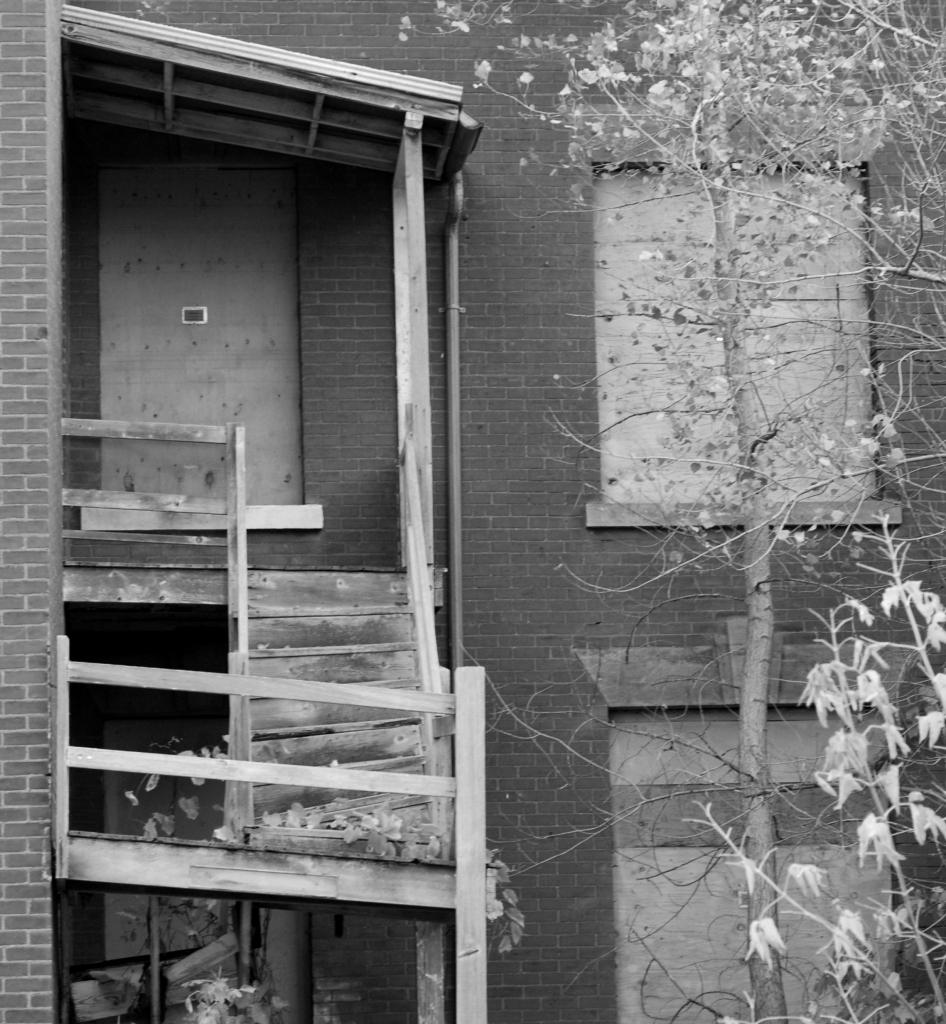What type of structure is located on the left side of the image? There is a wooden staircase on the left side of the image. What can be seen on the right side of the image? There are trees on the right side of the image. What is the main subject in the middle of the image? There is a house in the middle of the image. What type of sand can be seen on the ship in the image? There is no ship or sand present in the image. Is there a camera visible in the image? There is no camera visible in the image. 